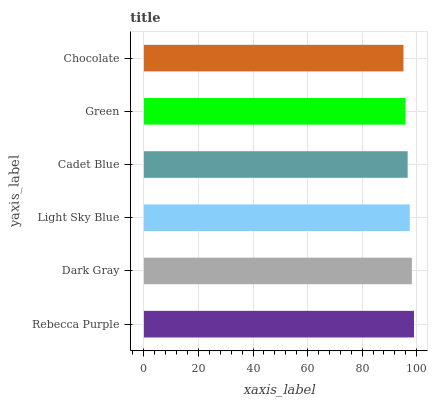Is Chocolate the minimum?
Answer yes or no. Yes. Is Rebecca Purple the maximum?
Answer yes or no. Yes. Is Dark Gray the minimum?
Answer yes or no. No. Is Dark Gray the maximum?
Answer yes or no. No. Is Rebecca Purple greater than Dark Gray?
Answer yes or no. Yes. Is Dark Gray less than Rebecca Purple?
Answer yes or no. Yes. Is Dark Gray greater than Rebecca Purple?
Answer yes or no. No. Is Rebecca Purple less than Dark Gray?
Answer yes or no. No. Is Light Sky Blue the high median?
Answer yes or no. Yes. Is Cadet Blue the low median?
Answer yes or no. Yes. Is Cadet Blue the high median?
Answer yes or no. No. Is Chocolate the low median?
Answer yes or no. No. 